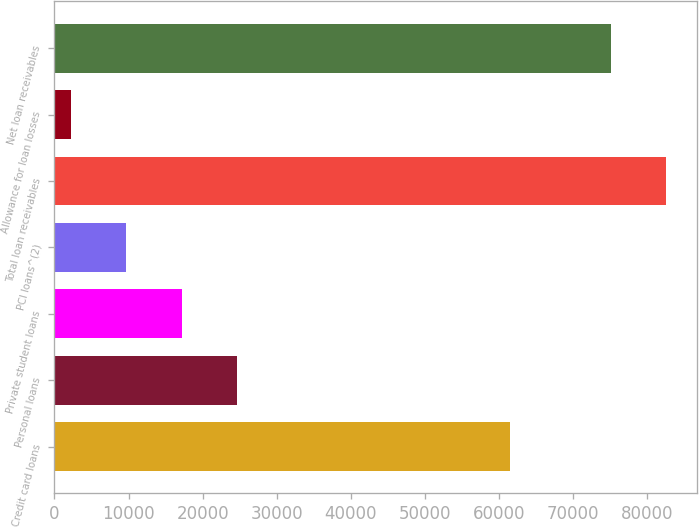<chart> <loc_0><loc_0><loc_500><loc_500><bar_chart><fcel>Credit card loans<fcel>Personal loans<fcel>Private student loans<fcel>PCI loans^(2)<fcel>Total loan receivables<fcel>Allowance for loan losses<fcel>Net loan receivables<nl><fcel>61522<fcel>24693.1<fcel>17184.4<fcel>9675.7<fcel>82595.7<fcel>2167<fcel>75087<nl></chart> 